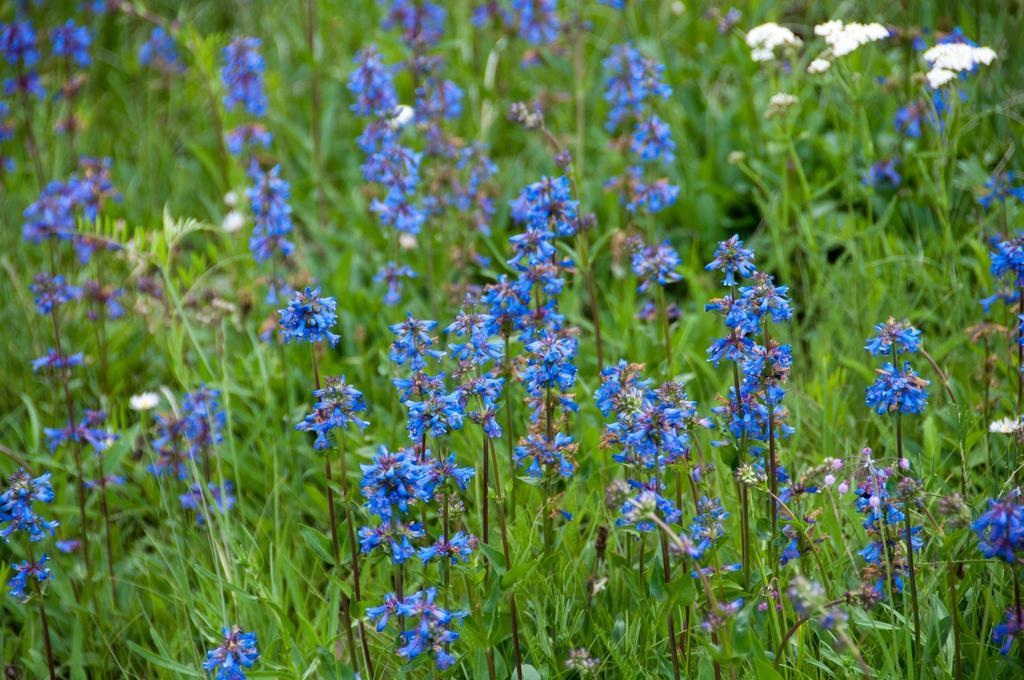How would you summarize this image in a sentence or two? In this picture I can observe blue color flowers. In the background I can observe plants on the ground. 